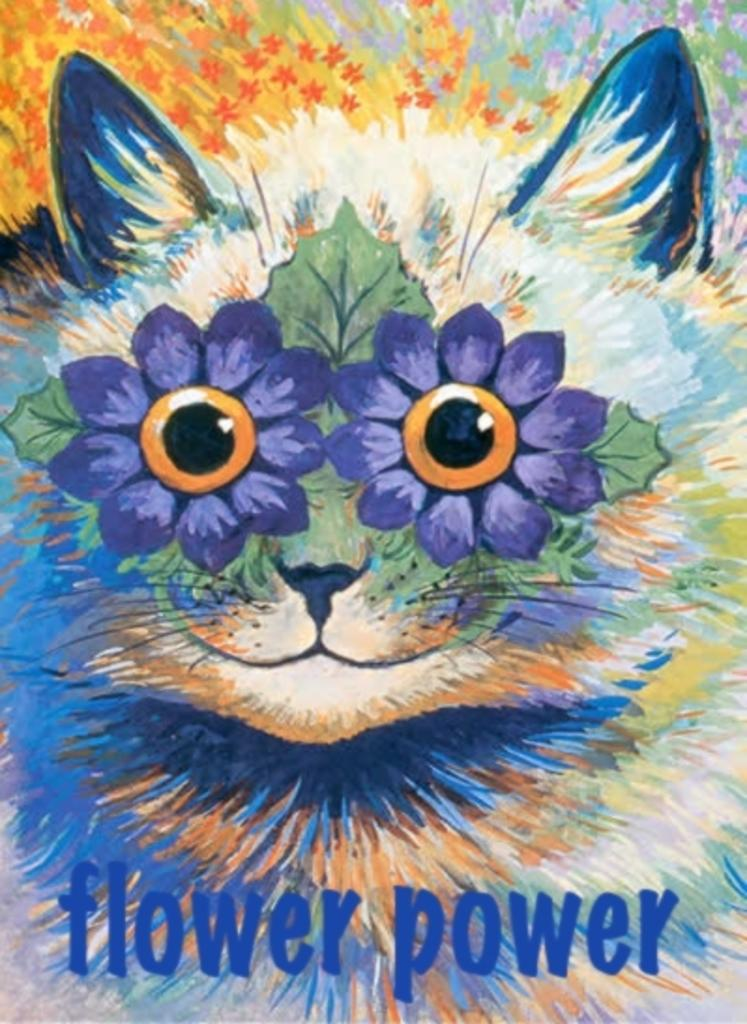What is depicted in the painting in the image? There is a painting of a cat in the image. What other elements can be seen in the image besides the painting? There are flowers visible in the image. Is there any text or marking at the bottom of the image? Yes, there is a watermark at the bottom of the image. How many plants are visible in the image? There is no mention of plants in the image; it features a painting of a cat and flowers. Can you see a hen in the image? There is no hen present in the image. 